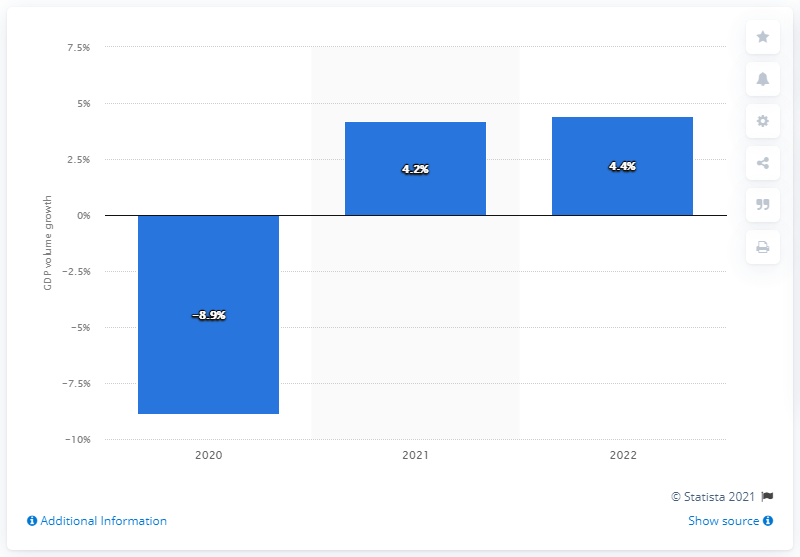Identify some key points in this picture. Italy's Gross Domestic Product (GDP) is forecasted to increase by 4.4% in 2022, according to recent estimates. 